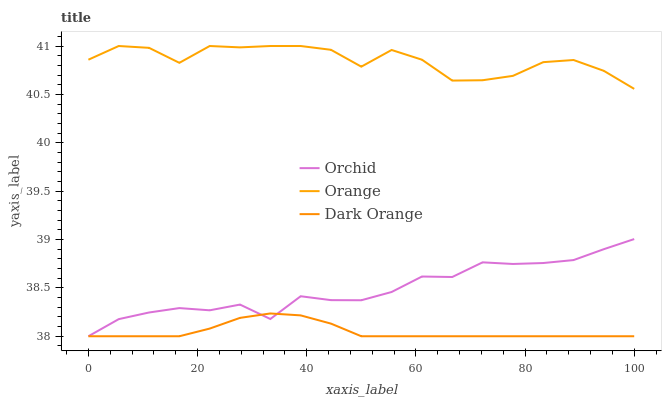Does Dark Orange have the minimum area under the curve?
Answer yes or no. Yes. Does Orange have the maximum area under the curve?
Answer yes or no. Yes. Does Orchid have the minimum area under the curve?
Answer yes or no. No. Does Orchid have the maximum area under the curve?
Answer yes or no. No. Is Dark Orange the smoothest?
Answer yes or no. Yes. Is Orange the roughest?
Answer yes or no. Yes. Is Orchid the smoothest?
Answer yes or no. No. Is Orchid the roughest?
Answer yes or no. No. Does Dark Orange have the lowest value?
Answer yes or no. Yes. Does Orange have the highest value?
Answer yes or no. Yes. Does Orchid have the highest value?
Answer yes or no. No. Is Dark Orange less than Orange?
Answer yes or no. Yes. Is Orange greater than Orchid?
Answer yes or no. Yes. Does Orchid intersect Dark Orange?
Answer yes or no. Yes. Is Orchid less than Dark Orange?
Answer yes or no. No. Is Orchid greater than Dark Orange?
Answer yes or no. No. Does Dark Orange intersect Orange?
Answer yes or no. No. 